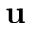<formula> <loc_0><loc_0><loc_500><loc_500>u</formula> 